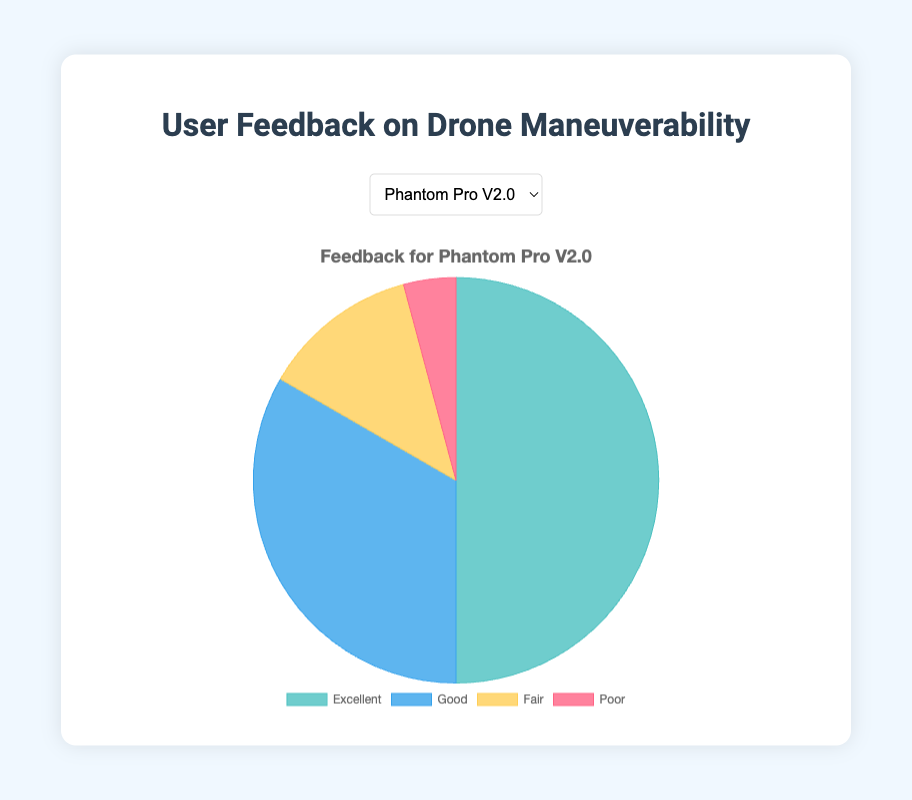How many total users gave feedback for the Phantom Pro V2.0? Sum the feedback values: 120 (Excellent) + 80 (Good) + 30 (Fair) + 10 (Poor) = 240
Answer: 240 Which drone model received the highest number of "Excellent" feedbacks? Compare the "Excellent" feedback values for each drone model: Phantom Pro V2.0 (120), Mavic Air 2 (150), Parrot Anafi (90), Skydio 2 (180). Skydio 2 has the highest with 180
Answer: Skydio 2 What is the percentage of "Good" feedback for the Mavic Air 2 relative to its total feedback? Calculate the percentage: (Good feedback / Total feedback) * 100. So, (60 / (150 + 60 + 20 + 5)) * 100 ≈ 25.53%
Answer: 25.53% Which model has the highest sum of "Fair" and "Poor" feedbacks? Sum the "Fair" and "Poor" values for each drone model: Phantom Pro V2.0 (30 + 10 = 40), Mavic Air 2 (20 + 5 = 25), Parrot Anafi (40 + 20 = 60), Skydio 2 (10 + 2 = 12). Parrot Anafi has the highest with 60
Answer: Parrot Anafi What is the ratio of "Excellent" to "Poor" feedback for the Skydio 2? Ratio = "Excellent" / "Poor". So, 180 / 2 = 90
Answer: 90 Which feedback category has the smallest proportion in the feedback for the Phantom Pro V2.0? Compare the proportions: Poor has 10 out of the 240 total feedbacks, which is the smallest proportion for Phantom Pro V2.0
Answer: Poor By how many does the "Fair" feedback for the Parrot Anafi exceed that of the Mavic Air 2? Difference = "Fair" feedback of Parrot Anafi - "Fair" feedback of Mavic Air 2. So, 40 - 20 = 20
Answer: 20 What fraction of total feedback for Phantom Pro V2.0 is categorized as "Excellent"? Fraction = "Excellent" / Total feedback. So, 120 / 240 = 1/2
Answer: 1/2 Compare the "Poor" feedback values of Phantom Pro V2.0 and Mavic Air 2 and determine the difference. Difference = "Poor" feedback of Phantom Pro V2.0 - "Poor" feedback of Mavic Air 2. So, 10 - 5 = 5
Answer: 5 What is the average number of "Good" feedbacks across all drone models? Calculate the average: (80 (Phantom Pro V2.0) + 60 (Mavic Air 2) + 70 (Parrot Anafi) + 50 (Skydio 2)) / 4 = 65
Answer: 65 